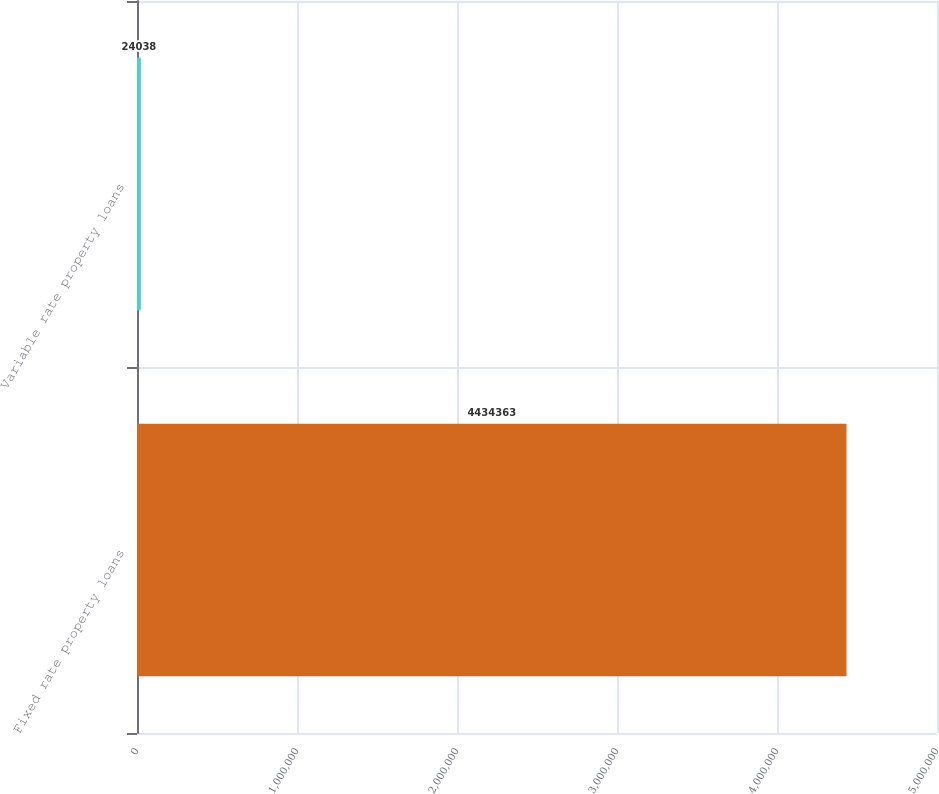Convert chart. <chart><loc_0><loc_0><loc_500><loc_500><bar_chart><fcel>Fixed rate property loans<fcel>Variable rate property loans<nl><fcel>4.43436e+06<fcel>24038<nl></chart> 